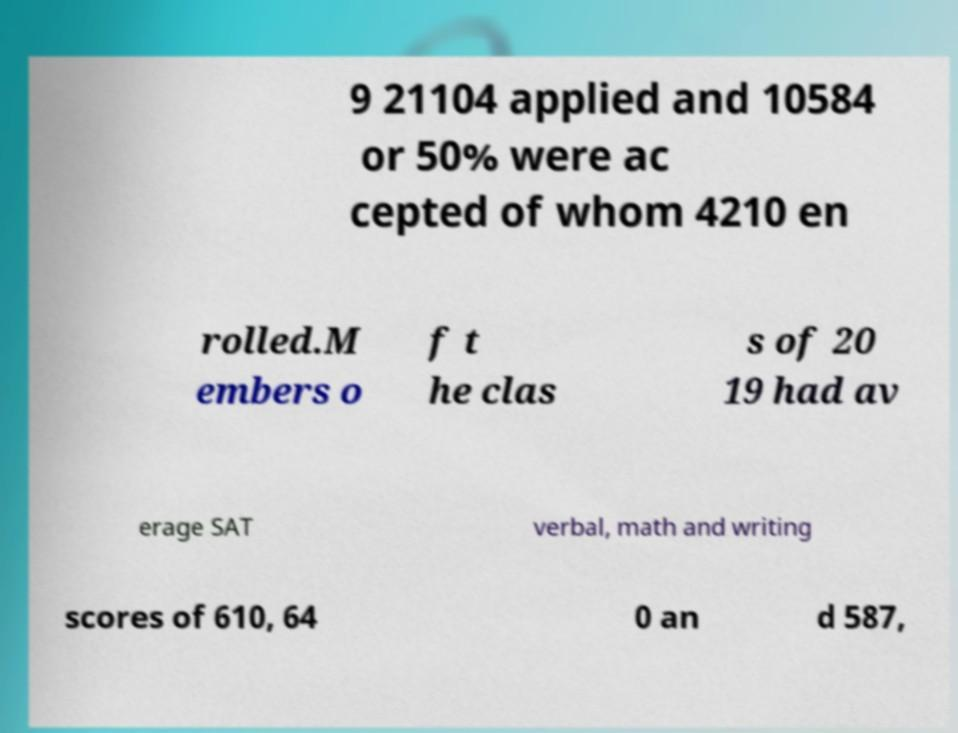What messages or text are displayed in this image? I need them in a readable, typed format. 9 21104 applied and 10584 or 50% were ac cepted of whom 4210 en rolled.M embers o f t he clas s of 20 19 had av erage SAT verbal, math and writing scores of 610, 64 0 an d 587, 